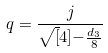Convert formula to latex. <formula><loc_0><loc_0><loc_500><loc_500>q = \frac { j } { \sqrt { [ } 4 ] { - \frac { d _ { 3 } } { 8 } } }</formula> 